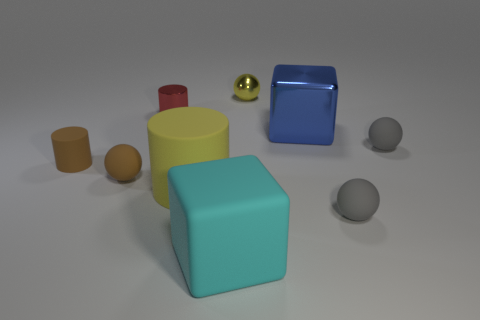There is a cyan object; is its size the same as the shiny object left of the cyan block?
Give a very brief answer. No. How many other things are the same material as the cyan block?
Your response must be concise. 5. How many objects are either balls that are behind the red thing or balls in front of the blue cube?
Give a very brief answer. 4. What is the material of the other thing that is the same shape as the large cyan matte thing?
Offer a very short reply. Metal. Are there any big red rubber cylinders?
Give a very brief answer. No. There is a cylinder that is both in front of the red object and right of the tiny rubber cylinder; what is its size?
Your answer should be compact. Large. There is a tiny red shiny thing; what shape is it?
Offer a terse response. Cylinder. Are there any tiny spheres that are behind the gray thing that is behind the big rubber cylinder?
Offer a terse response. Yes. What material is the other cube that is the same size as the blue metallic block?
Keep it short and to the point. Rubber. Are there any yellow cylinders of the same size as the cyan thing?
Ensure brevity in your answer.  Yes. 